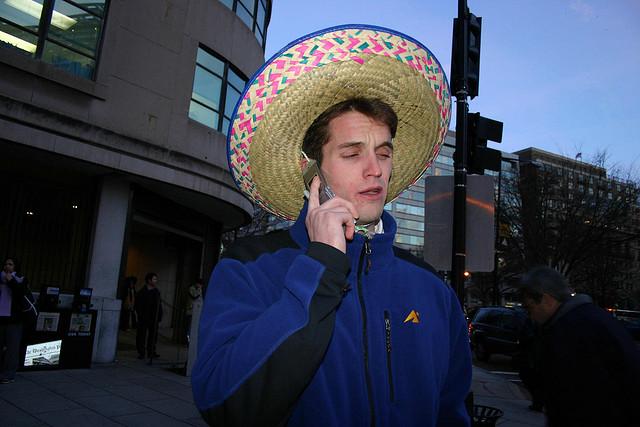Is his hat large?
Short answer required. Yes. Is the bear life size?
Quick response, please. No. What colors are the man's jacket?
Write a very short answer. Blue. Which item is reminiscent of a Latin country?
Answer briefly. Sombrero. 